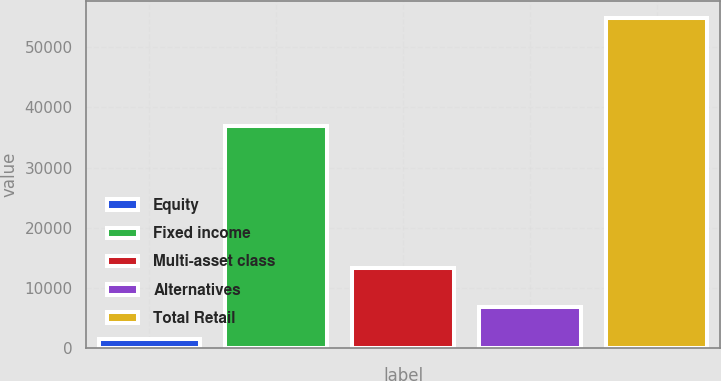Convert chart to OTSL. <chart><loc_0><loc_0><loc_500><loc_500><bar_chart><fcel>Equity<fcel>Fixed income<fcel>Multi-asset class<fcel>Alternatives<fcel>Total Retail<nl><fcel>1582<fcel>36995<fcel>13366<fcel>6918.2<fcel>54944<nl></chart> 